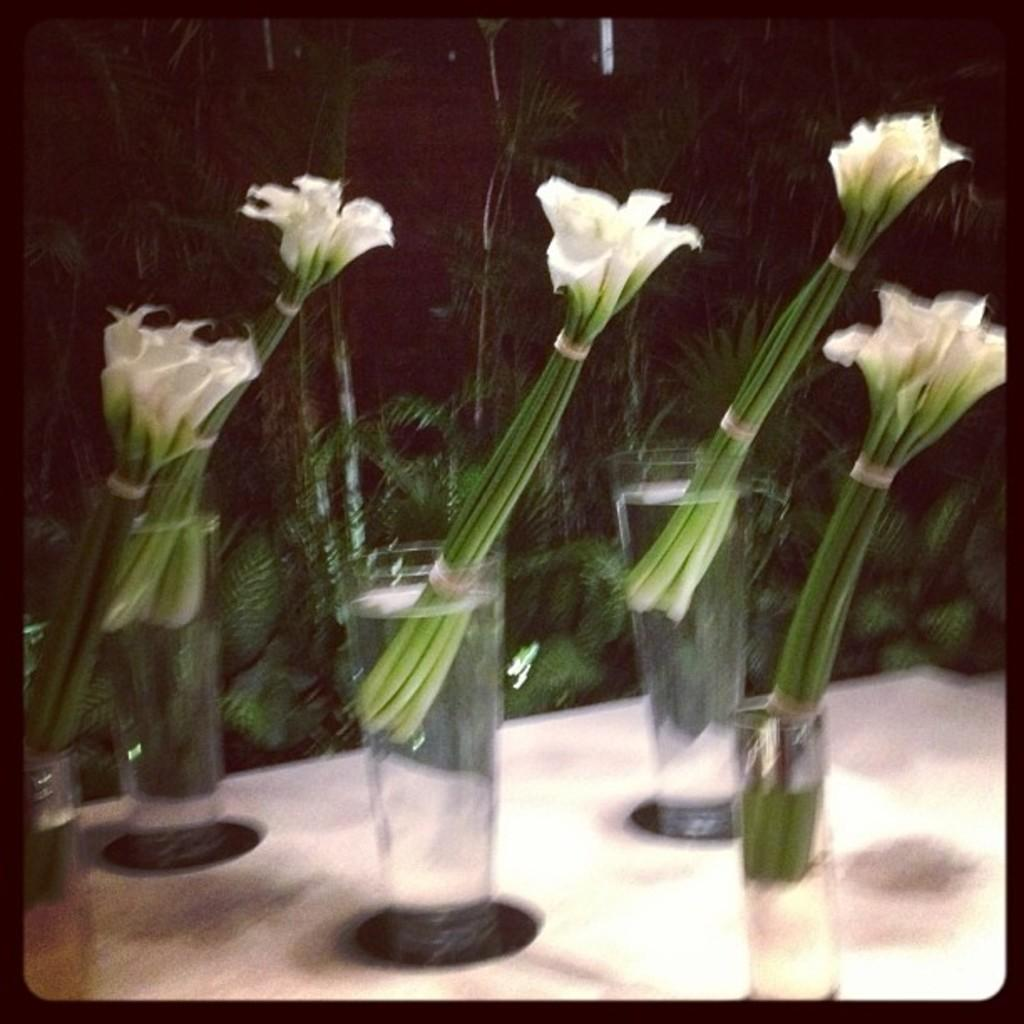How many bunches of flowers are in the image? There are five bunches of flowers in the image. What are the flowers placed in? The flowers are in a glass of water. Where are the glasses with flowers located? The glasses with flowers are placed on a table. What can be seen in the background of the image? There are trees visible in the background of the image. What is the chance of the flowers growing a nose in the image? There is no chance of the flowers growing a nose in the image, as flowers do not have noses. 